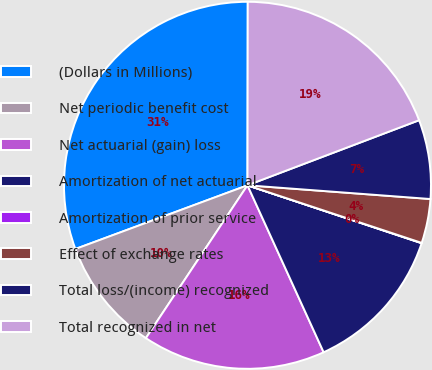Convert chart to OTSL. <chart><loc_0><loc_0><loc_500><loc_500><pie_chart><fcel>(Dollars in Millions)<fcel>Net periodic benefit cost<fcel>Net actuarial (gain) loss<fcel>Amortization of net actuarial<fcel>Amortization of prior service<fcel>Effect of exchange rates<fcel>Total loss/(income) recognized<fcel>Total recognized in net<nl><fcel>30.67%<fcel>10.02%<fcel>16.15%<fcel>13.08%<fcel>0.03%<fcel>3.89%<fcel>6.96%<fcel>19.21%<nl></chart> 